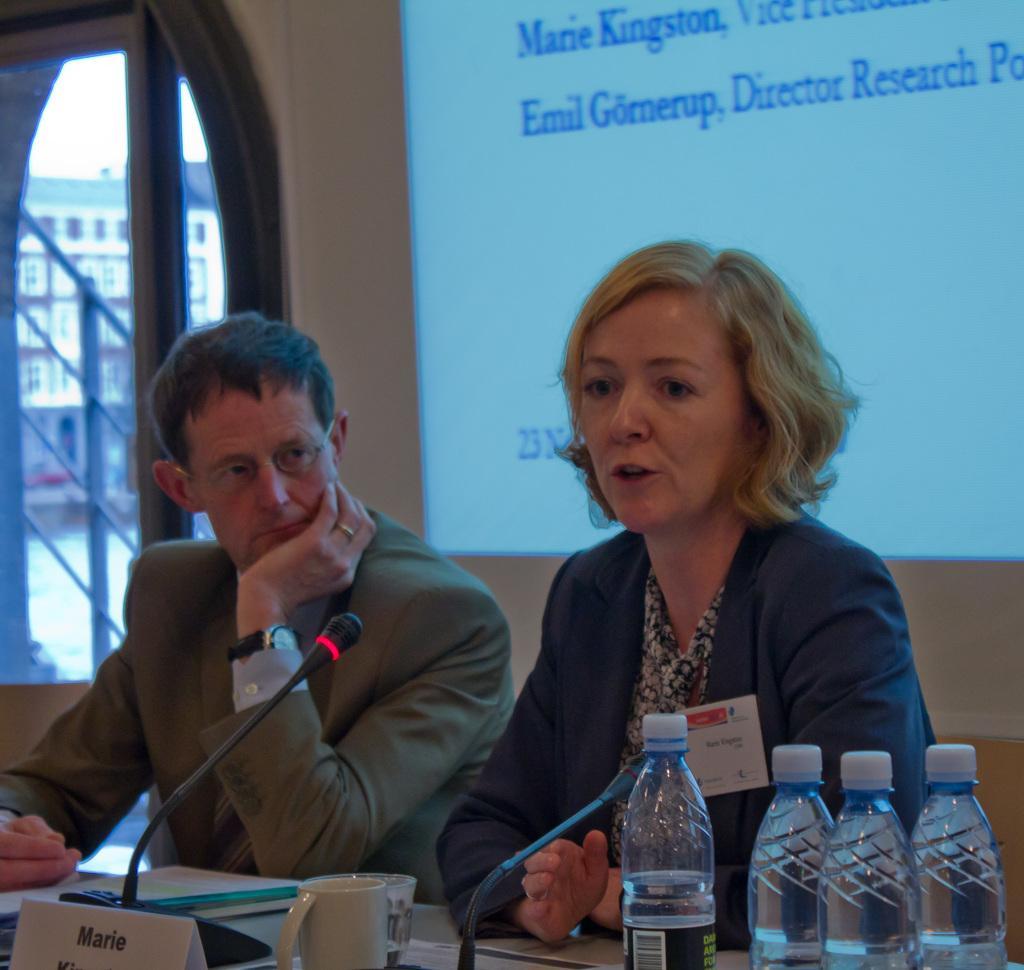How would you summarize this image in a sentence or two? A woman is sitting in a chair and speaking. There is a man beside her. There are mics,cup and some bottles on the table. There is a screen behind them. 